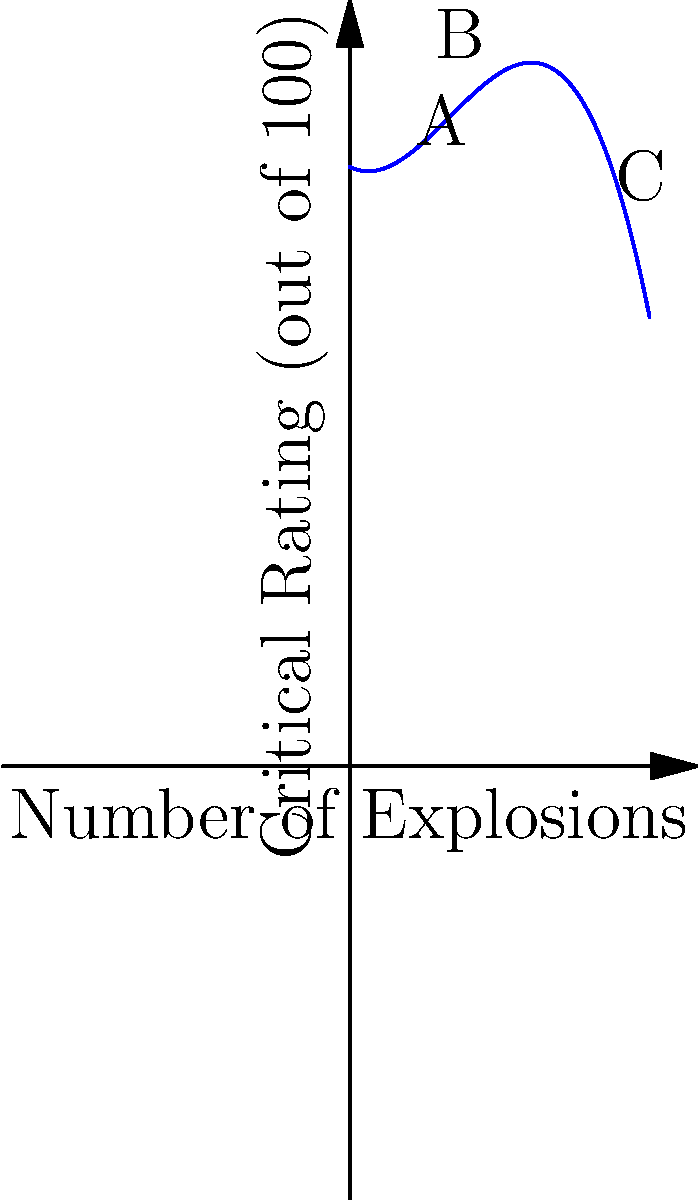In this polynomial graph showing the relationship between the number of explosions in an action movie and its critical reception, which point represents the "sweet spot" where the movie achieves its highest critical rating? To determine the "sweet spot" where the movie achieves its highest critical rating, we need to analyze the graph:

1. The y-axis represents the critical rating (out of 100), while the x-axis shows the number of explosions.

2. The graph is a polynomial function, creating a curve that rises and then falls.

3. We can see three labeled points on the graph: A, B, and C.

4. Point A is at a relatively low number of explosions with a moderate critical rating.

5. Point C is at a high number of explosions with a lower critical rating.

6. Point B is in the middle and appears to be at the peak of the curve, representing the highest point on the y-axis (critical rating).

7. This suggests that Point B represents the optimal balance between the number of explosions and critical reception.

Therefore, Point B represents the "sweet spot" where the movie achieves its highest critical rating, balancing spectacle with critical appeal.
Answer: Point B 